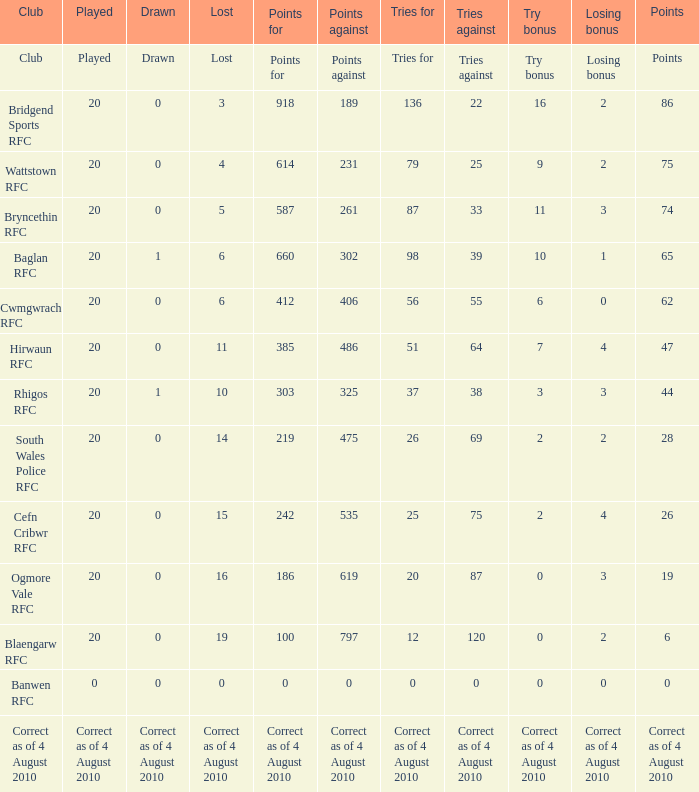Parse the full table. {'header': ['Club', 'Played', 'Drawn', 'Lost', 'Points for', 'Points against', 'Tries for', 'Tries against', 'Try bonus', 'Losing bonus', 'Points'], 'rows': [['Club', 'Played', 'Drawn', 'Lost', 'Points for', 'Points against', 'Tries for', 'Tries against', 'Try bonus', 'Losing bonus', 'Points'], ['Bridgend Sports RFC', '20', '0', '3', '918', '189', '136', '22', '16', '2', '86'], ['Wattstown RFC', '20', '0', '4', '614', '231', '79', '25', '9', '2', '75'], ['Bryncethin RFC', '20', '0', '5', '587', '261', '87', '33', '11', '3', '74'], ['Baglan RFC', '20', '1', '6', '660', '302', '98', '39', '10', '1', '65'], ['Cwmgwrach RFC', '20', '0', '6', '412', '406', '56', '55', '6', '0', '62'], ['Hirwaun RFC', '20', '0', '11', '385', '486', '51', '64', '7', '4', '47'], ['Rhigos RFC', '20', '1', '10', '303', '325', '37', '38', '3', '3', '44'], ['South Wales Police RFC', '20', '0', '14', '219', '475', '26', '69', '2', '2', '28'], ['Cefn Cribwr RFC', '20', '0', '15', '242', '535', '25', '75', '2', '4', '26'], ['Ogmore Vale RFC', '20', '0', '16', '186', '619', '20', '87', '0', '3', '19'], ['Blaengarw RFC', '20', '0', '19', '100', '797', '12', '120', '0', '2', '6'], ['Banwen RFC', '0', '0', '0', '0', '0', '0', '0', '0', '0', '0'], ['Correct as of 4 August 2010', 'Correct as of 4 August 2010', 'Correct as of 4 August 2010', 'Correct as of 4 August 2010', 'Correct as of 4 August 2010', 'Correct as of 4 August 2010', 'Correct as of 4 August 2010', 'Correct as of 4 August 2010', 'Correct as of 4 August 2010', 'Correct as of 4 August 2010', 'Correct as of 4 August 2010']]} What becomes lost when the opposing points are 231? 4.0. 